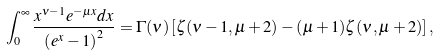Convert formula to latex. <formula><loc_0><loc_0><loc_500><loc_500>\int _ { 0 } ^ { \infty } \frac { x ^ { \nu - 1 } e ^ { - \mu x } d x } { \left ( e ^ { x } - 1 \right ) ^ { 2 } } = \Gamma ( \nu ) \left [ \zeta ( \nu - 1 , \mu + 2 ) - ( \mu + 1 ) \zeta ( \nu , \mu + 2 ) \right ] ,</formula> 